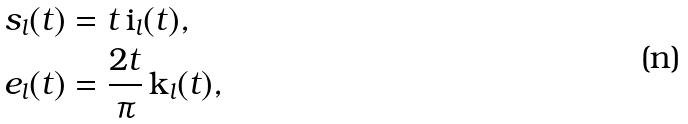<formula> <loc_0><loc_0><loc_500><loc_500>s _ { l } ( t ) & = t \, \text {i} _ { l } ( t ) , \\ e _ { l } ( t ) & = \frac { 2 t } { \pi } \, \text {k} _ { l } ( t ) ,</formula> 